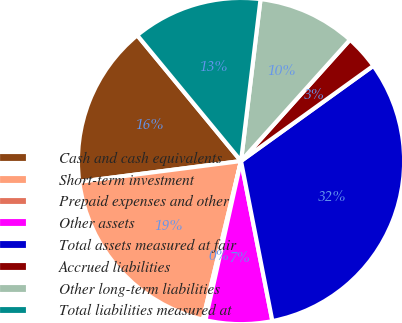Convert chart. <chart><loc_0><loc_0><loc_500><loc_500><pie_chart><fcel>Cash and cash equivalents<fcel>Short-term investment<fcel>Prepaid expenses and other<fcel>Other assets<fcel>Total assets measured at fair<fcel>Accrued liabilities<fcel>Other long-term liabilities<fcel>Total liabilities measured at<nl><fcel>16.05%<fcel>19.21%<fcel>0.26%<fcel>6.58%<fcel>31.85%<fcel>3.42%<fcel>9.74%<fcel>12.89%<nl></chart> 